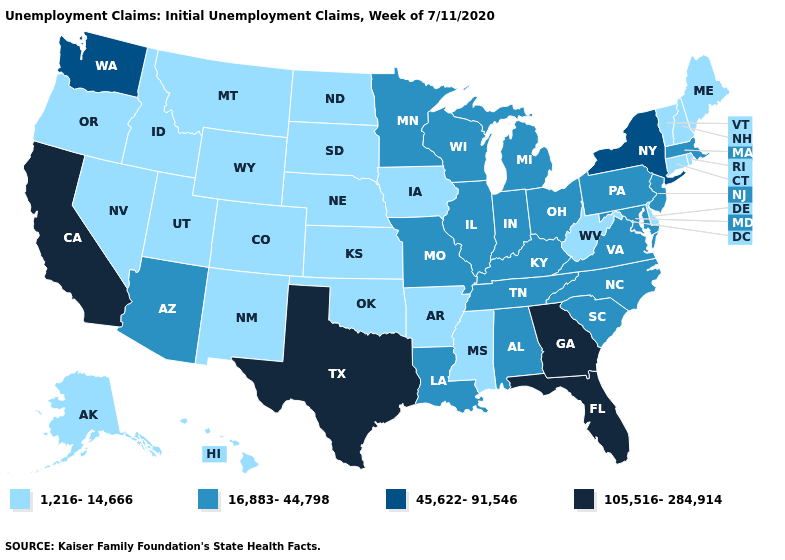Does the map have missing data?
Keep it brief. No. What is the highest value in states that border Wyoming?
Write a very short answer. 1,216-14,666. What is the value of West Virginia?
Keep it brief. 1,216-14,666. Name the states that have a value in the range 105,516-284,914?
Short answer required. California, Florida, Georgia, Texas. What is the value of Wyoming?
Keep it brief. 1,216-14,666. Does California have the highest value in the USA?
Write a very short answer. Yes. Name the states that have a value in the range 1,216-14,666?
Short answer required. Alaska, Arkansas, Colorado, Connecticut, Delaware, Hawaii, Idaho, Iowa, Kansas, Maine, Mississippi, Montana, Nebraska, Nevada, New Hampshire, New Mexico, North Dakota, Oklahoma, Oregon, Rhode Island, South Dakota, Utah, Vermont, West Virginia, Wyoming. Name the states that have a value in the range 45,622-91,546?
Quick response, please. New York, Washington. Among the states that border Kansas , does Colorado have the highest value?
Concise answer only. No. What is the lowest value in states that border Kentucky?
Concise answer only. 1,216-14,666. Name the states that have a value in the range 16,883-44,798?
Write a very short answer. Alabama, Arizona, Illinois, Indiana, Kentucky, Louisiana, Maryland, Massachusetts, Michigan, Minnesota, Missouri, New Jersey, North Carolina, Ohio, Pennsylvania, South Carolina, Tennessee, Virginia, Wisconsin. Name the states that have a value in the range 105,516-284,914?
Keep it brief. California, Florida, Georgia, Texas. Does California have a higher value than Texas?
Short answer required. No. Which states have the lowest value in the USA?
Give a very brief answer. Alaska, Arkansas, Colorado, Connecticut, Delaware, Hawaii, Idaho, Iowa, Kansas, Maine, Mississippi, Montana, Nebraska, Nevada, New Hampshire, New Mexico, North Dakota, Oklahoma, Oregon, Rhode Island, South Dakota, Utah, Vermont, West Virginia, Wyoming. 